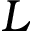<formula> <loc_0><loc_0><loc_500><loc_500>L</formula> 